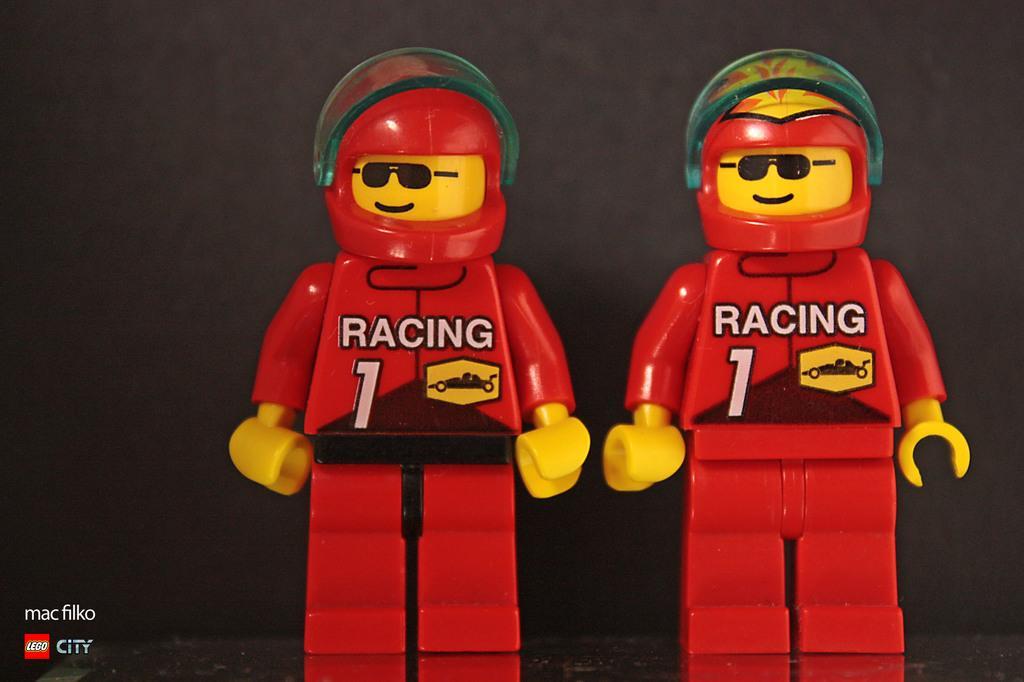Describe this image in one or two sentences. In this image we can see toys. 